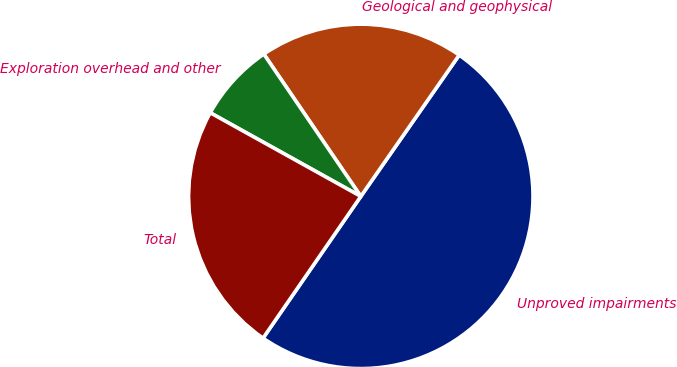<chart> <loc_0><loc_0><loc_500><loc_500><pie_chart><fcel>Unproved impairments<fcel>Geological and geophysical<fcel>Exploration overhead and other<fcel>Total<nl><fcel>49.93%<fcel>19.2%<fcel>7.41%<fcel>23.46%<nl></chart> 